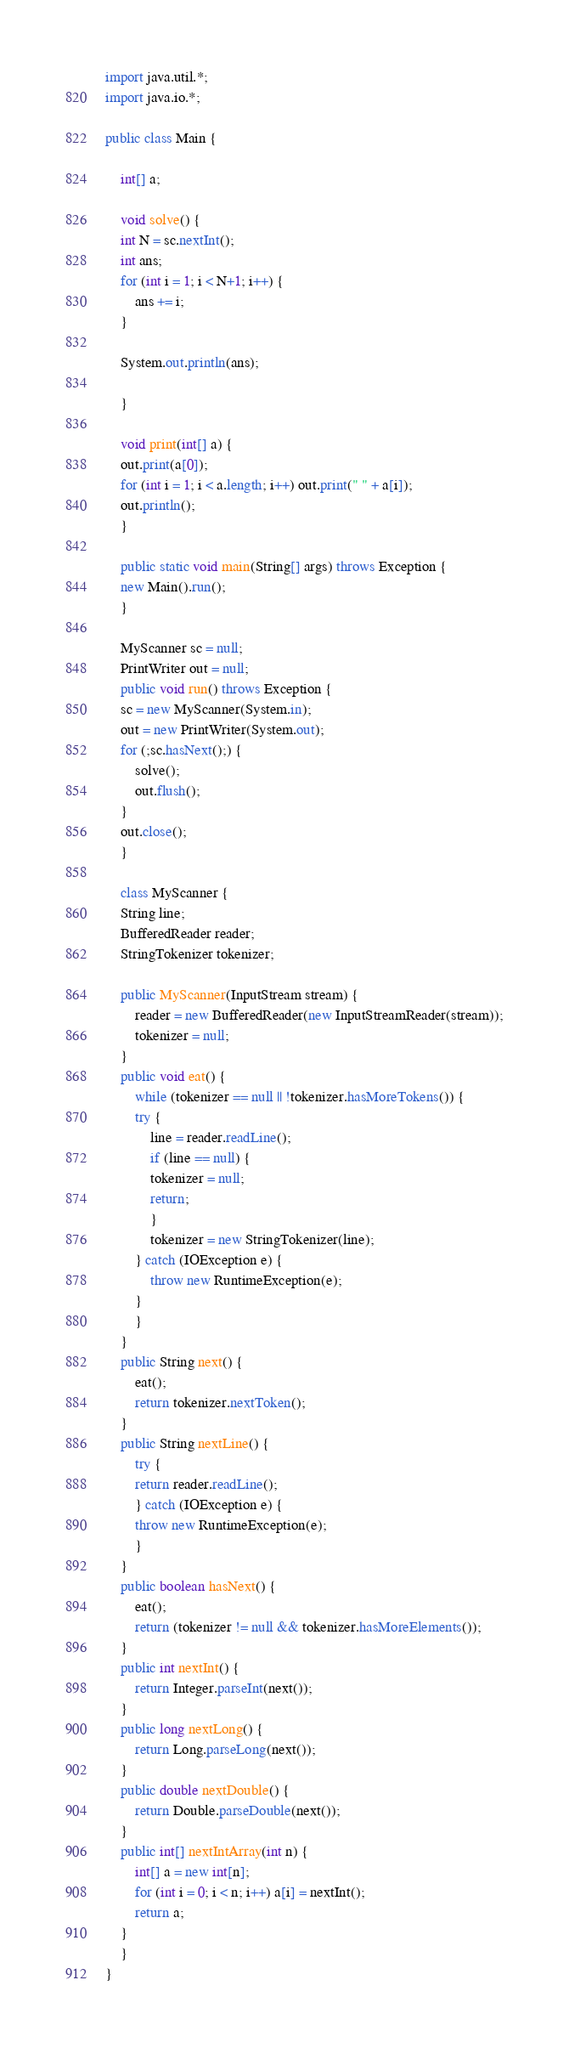Convert code to text. <code><loc_0><loc_0><loc_500><loc_500><_Java_>import java.util.*;
import java.io.*;

public class Main {

    int[] a;

    void solve() {
	int N = sc.nextInt();
	int ans;
	for (int i = 1; i < N+1; i++) {
	    ans += i;
	}

	System.out.println(ans);

    }

    void print(int[] a) {
	out.print(a[0]);
	for (int i = 1; i < a.length; i++) out.print(" " + a[i]);
	out.println();
    }

    public static void main(String[] args) throws Exception {
	new Main().run();
    }

    MyScanner sc = null;
    PrintWriter out = null;
    public void run() throws Exception {
	sc = new MyScanner(System.in);
	out = new PrintWriter(System.out);
	for (;sc.hasNext();) {
	    solve();
	    out.flush();
	}
	out.close();
    }

    class MyScanner {
	String line;
	BufferedReader reader;
	StringTokenizer tokenizer;

	public MyScanner(InputStream stream) {
	    reader = new BufferedReader(new InputStreamReader(stream));
	    tokenizer = null;
	}
	public void eat() {
	    while (tokenizer == null || !tokenizer.hasMoreTokens()) {
		try {
		    line = reader.readLine();
		    if (line == null) {
			tokenizer = null;
			return;
		    }
		    tokenizer = new StringTokenizer(line);
		} catch (IOException e) {
		    throw new RuntimeException(e);
		}
	    }
	}
	public String next() {
	    eat();
	    return tokenizer.nextToken();
	}
	public String nextLine() {
	    try {
		return reader.readLine();
	    } catch (IOException e) {
		throw new RuntimeException(e);
	    }
	}
	public boolean hasNext() {
	    eat();
	    return (tokenizer != null && tokenizer.hasMoreElements());
	}
	public int nextInt() {
	    return Integer.parseInt(next());
	}
	public long nextLong() {
	    return Long.parseLong(next());
	}
	public double nextDouble() {
	    return Double.parseDouble(next());
	}
	public int[] nextIntArray(int n) {
	    int[] a = new int[n];
	    for (int i = 0; i < n; i++) a[i] = nextInt();
	    return a;
	}
    }
}
</code> 